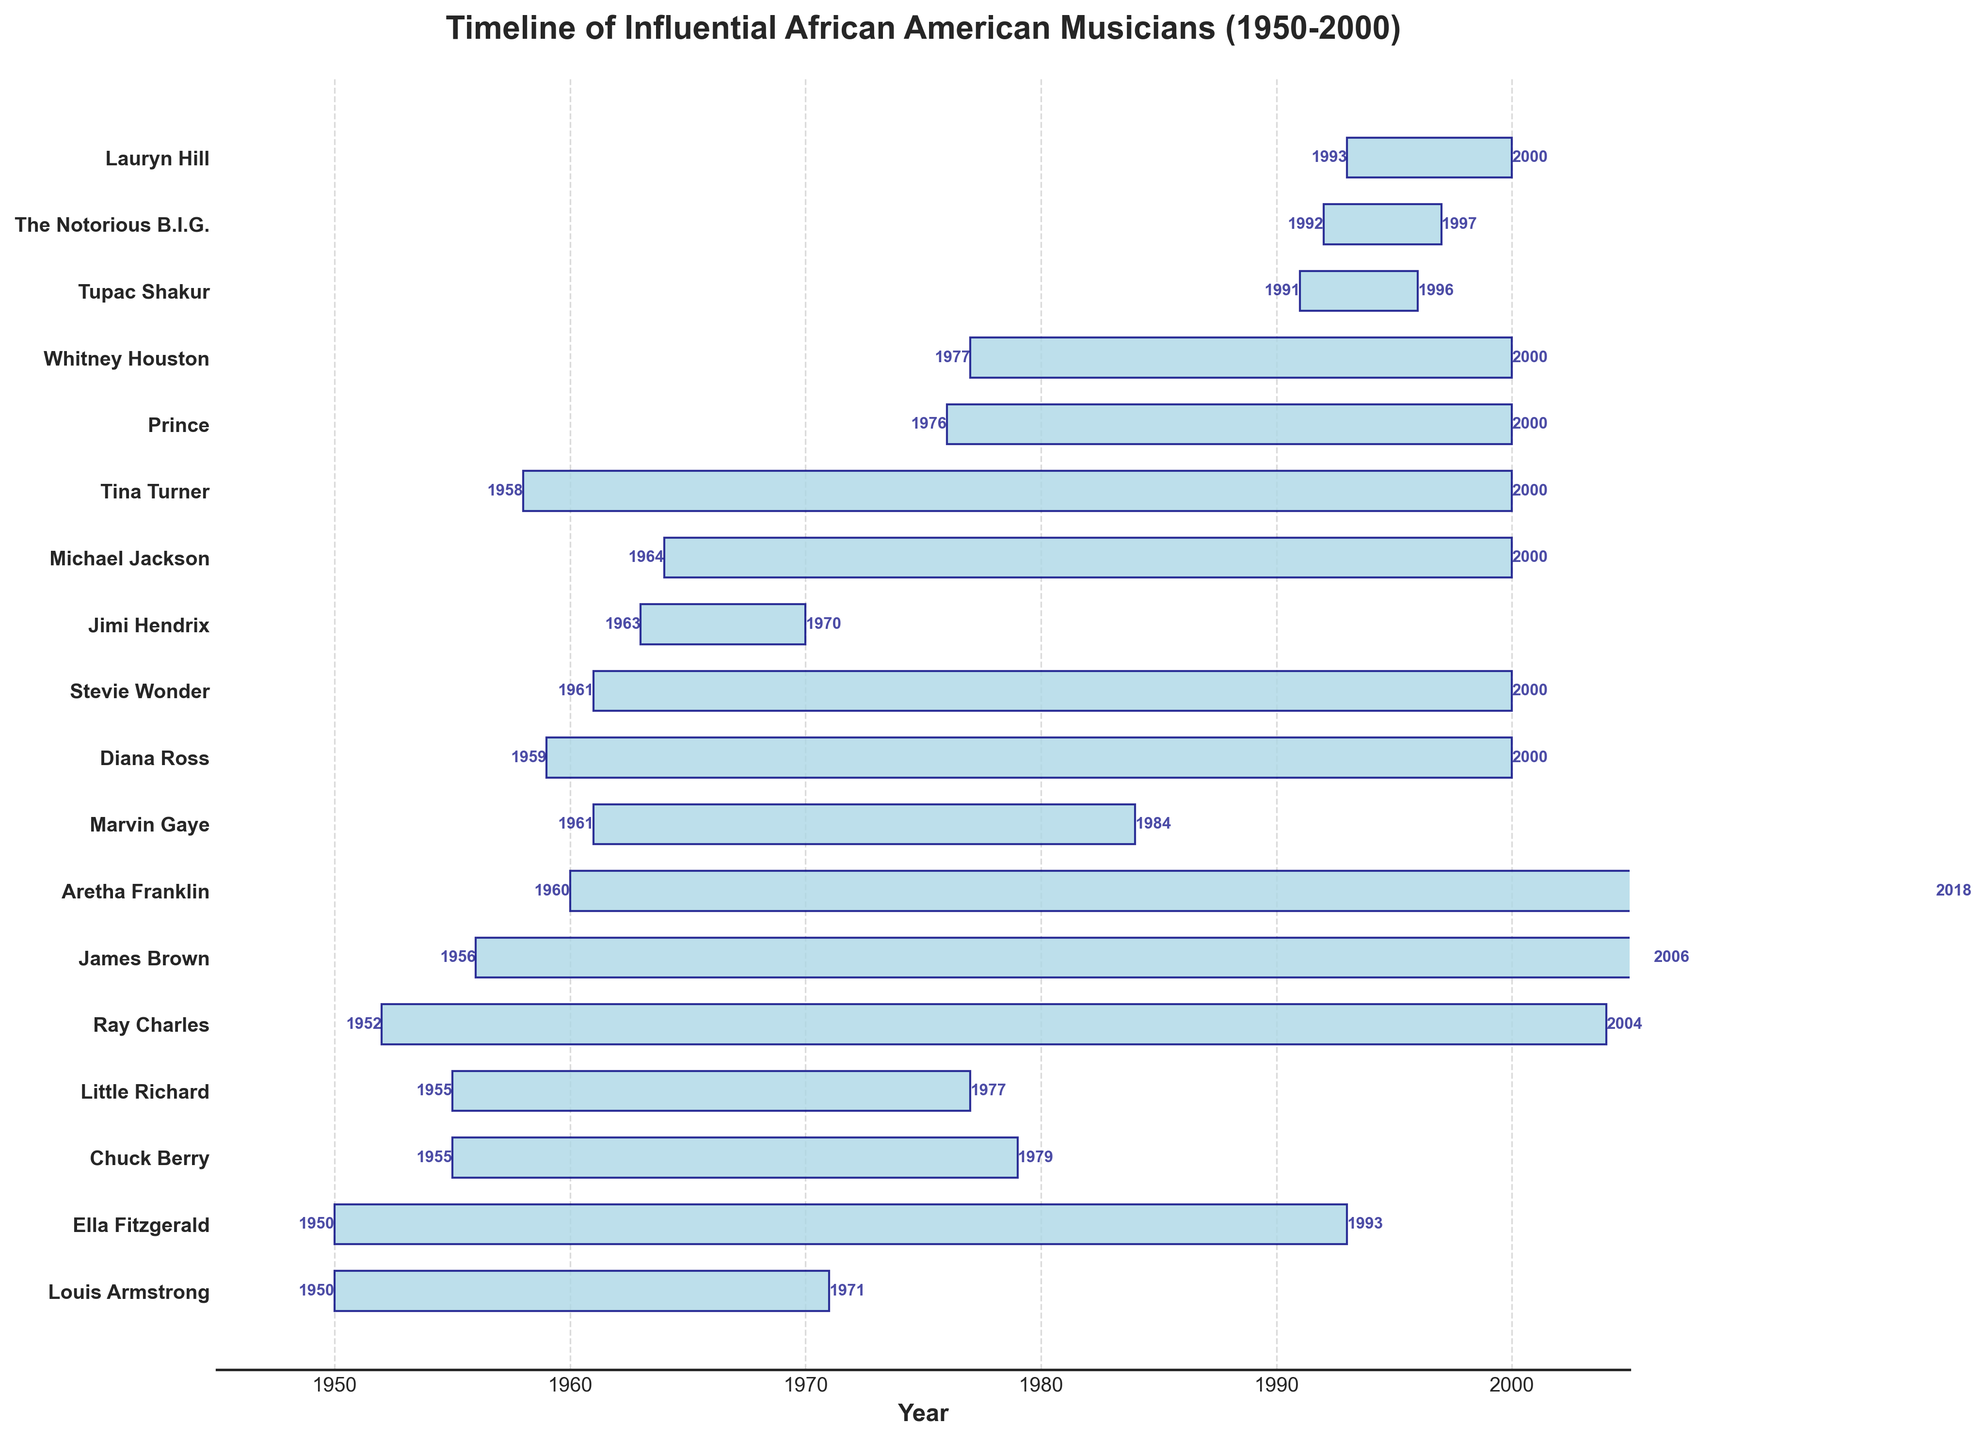Was Ella Fitzgerald active longer than Louis Armstrong? To determine if Ella Fitzgerald was active longer than Louis Armstrong, we need to calculate the duration of their active years. Ella Fitzgerald's active years were from 1950 to 1993, which is 43 years (1993-1950). Louis Armstrong's active years were from 1950 to 1971, which is 21 years (1971-1950). Since 43 years is longer than 21 years, Ella Fitzgerald was active longer than Louis Armstrong.
Answer: Yes Which musician had the shortest career span? To determine the shortest career span, we calculate the active years for each musician and compare them. Tupac Shakur was active from 1991 to 1996, which is 5 years (1996-1991). The Notorious B.I.G. was active from 1992 to 1997, which is 5 years (1997-1992). Since both have the same shortest span of 5 years, the answer is both Tupac Shakur and The Notorious B.I.G.
Answer: Tupac Shakur and The Notorious B.I.G Did Michael Jackson or Stevie Wonder have a longer active period? To determine who had a longer active period, we need to calculate the number of active years for both. Michael Jackson's active years were from 1964 to 2000, which is 36 years (2000-1964). Stevie Wonder's active years were from 1961 to 2000, which is 39 years (2000-1961). Since 39 years is longer than 36 years, Stevie Wonder had a longer active period than Michael Jackson.
Answer: Stevie Wonder What's the total number of active years for musicians who started before 1960? First, identify the musicians who started before 1960 and calculate their active years. Louis Armstrong (1950-1971) = 21 years, Ella Fitzgerald (1950-1993) = 43 years, Ray Charles (1952-2004) = 52 years, Chuck Berry (1955-1979) = 24 years, Little Richard (1955-1977) = 22 years. Sum their years: 21 + 43 + 52 + 24 + 22 = 162 years.
Answer: 162 years Is there any musician whose active years overlap completely with Marvin Gaye's active years (1961-1984)? To determine this, we compare Marvin Gaye's active years to those of other musicians to see if any musician's active years are fully within 1961-1984. Jimi Hendrix (1963-1970) and Michael Jackson (1964-2000) have some overlapping years, but Michael Jackson's career extends past 1984. Jimi Hendrix's career (1963-1970) falls completely within Marvin Gaye's time range (1961-1984).
Answer: Jimi Hendrix Who started their career most recently among the musicians listed? Identify the latest starting year among the musicians. Lauryn Hill started in 1993, which is the most recent year compared to other musicians listed.
Answer: Lauryn Hill 